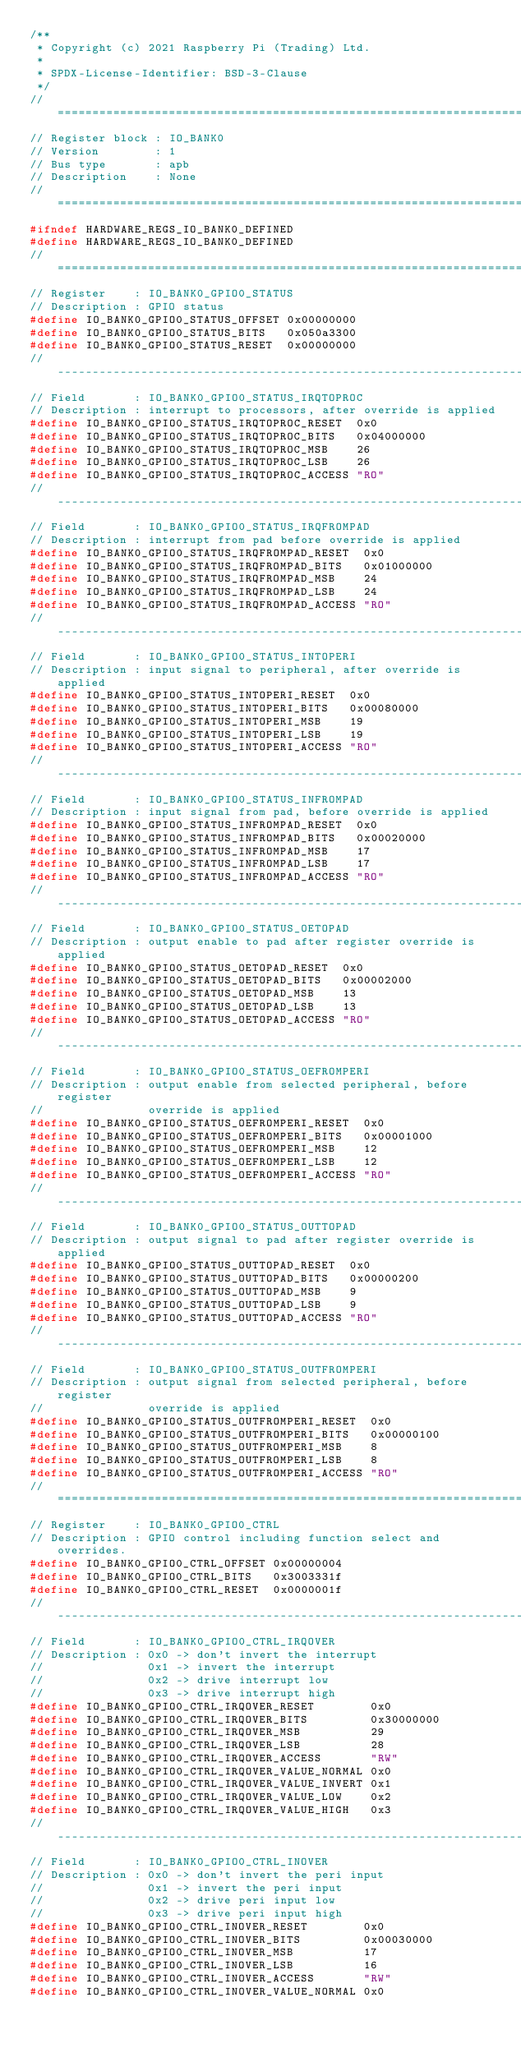<code> <loc_0><loc_0><loc_500><loc_500><_C_>/**
 * Copyright (c) 2021 Raspberry Pi (Trading) Ltd.
 *
 * SPDX-License-Identifier: BSD-3-Clause
 */
// =============================================================================
// Register block : IO_BANK0
// Version        : 1
// Bus type       : apb
// Description    : None
// =============================================================================
#ifndef HARDWARE_REGS_IO_BANK0_DEFINED
#define HARDWARE_REGS_IO_BANK0_DEFINED
// =============================================================================
// Register    : IO_BANK0_GPIO0_STATUS
// Description : GPIO status
#define IO_BANK0_GPIO0_STATUS_OFFSET 0x00000000
#define IO_BANK0_GPIO0_STATUS_BITS   0x050a3300
#define IO_BANK0_GPIO0_STATUS_RESET  0x00000000
// -----------------------------------------------------------------------------
// Field       : IO_BANK0_GPIO0_STATUS_IRQTOPROC
// Description : interrupt to processors, after override is applied
#define IO_BANK0_GPIO0_STATUS_IRQTOPROC_RESET  0x0
#define IO_BANK0_GPIO0_STATUS_IRQTOPROC_BITS   0x04000000
#define IO_BANK0_GPIO0_STATUS_IRQTOPROC_MSB    26
#define IO_BANK0_GPIO0_STATUS_IRQTOPROC_LSB    26
#define IO_BANK0_GPIO0_STATUS_IRQTOPROC_ACCESS "RO"
// -----------------------------------------------------------------------------
// Field       : IO_BANK0_GPIO0_STATUS_IRQFROMPAD
// Description : interrupt from pad before override is applied
#define IO_BANK0_GPIO0_STATUS_IRQFROMPAD_RESET  0x0
#define IO_BANK0_GPIO0_STATUS_IRQFROMPAD_BITS   0x01000000
#define IO_BANK0_GPIO0_STATUS_IRQFROMPAD_MSB    24
#define IO_BANK0_GPIO0_STATUS_IRQFROMPAD_LSB    24
#define IO_BANK0_GPIO0_STATUS_IRQFROMPAD_ACCESS "RO"
// -----------------------------------------------------------------------------
// Field       : IO_BANK0_GPIO0_STATUS_INTOPERI
// Description : input signal to peripheral, after override is applied
#define IO_BANK0_GPIO0_STATUS_INTOPERI_RESET  0x0
#define IO_BANK0_GPIO0_STATUS_INTOPERI_BITS   0x00080000
#define IO_BANK0_GPIO0_STATUS_INTOPERI_MSB    19
#define IO_BANK0_GPIO0_STATUS_INTOPERI_LSB    19
#define IO_BANK0_GPIO0_STATUS_INTOPERI_ACCESS "RO"
// -----------------------------------------------------------------------------
// Field       : IO_BANK0_GPIO0_STATUS_INFROMPAD
// Description : input signal from pad, before override is applied
#define IO_BANK0_GPIO0_STATUS_INFROMPAD_RESET  0x0
#define IO_BANK0_GPIO0_STATUS_INFROMPAD_BITS   0x00020000
#define IO_BANK0_GPIO0_STATUS_INFROMPAD_MSB    17
#define IO_BANK0_GPIO0_STATUS_INFROMPAD_LSB    17
#define IO_BANK0_GPIO0_STATUS_INFROMPAD_ACCESS "RO"
// -----------------------------------------------------------------------------
// Field       : IO_BANK0_GPIO0_STATUS_OETOPAD
// Description : output enable to pad after register override is applied
#define IO_BANK0_GPIO0_STATUS_OETOPAD_RESET  0x0
#define IO_BANK0_GPIO0_STATUS_OETOPAD_BITS   0x00002000
#define IO_BANK0_GPIO0_STATUS_OETOPAD_MSB    13
#define IO_BANK0_GPIO0_STATUS_OETOPAD_LSB    13
#define IO_BANK0_GPIO0_STATUS_OETOPAD_ACCESS "RO"
// -----------------------------------------------------------------------------
// Field       : IO_BANK0_GPIO0_STATUS_OEFROMPERI
// Description : output enable from selected peripheral, before register
//               override is applied
#define IO_BANK0_GPIO0_STATUS_OEFROMPERI_RESET  0x0
#define IO_BANK0_GPIO0_STATUS_OEFROMPERI_BITS   0x00001000
#define IO_BANK0_GPIO0_STATUS_OEFROMPERI_MSB    12
#define IO_BANK0_GPIO0_STATUS_OEFROMPERI_LSB    12
#define IO_BANK0_GPIO0_STATUS_OEFROMPERI_ACCESS "RO"
// -----------------------------------------------------------------------------
// Field       : IO_BANK0_GPIO0_STATUS_OUTTOPAD
// Description : output signal to pad after register override is applied
#define IO_BANK0_GPIO0_STATUS_OUTTOPAD_RESET  0x0
#define IO_BANK0_GPIO0_STATUS_OUTTOPAD_BITS   0x00000200
#define IO_BANK0_GPIO0_STATUS_OUTTOPAD_MSB    9
#define IO_BANK0_GPIO0_STATUS_OUTTOPAD_LSB    9
#define IO_BANK0_GPIO0_STATUS_OUTTOPAD_ACCESS "RO"
// -----------------------------------------------------------------------------
// Field       : IO_BANK0_GPIO0_STATUS_OUTFROMPERI
// Description : output signal from selected peripheral, before register
//               override is applied
#define IO_BANK0_GPIO0_STATUS_OUTFROMPERI_RESET  0x0
#define IO_BANK0_GPIO0_STATUS_OUTFROMPERI_BITS   0x00000100
#define IO_BANK0_GPIO0_STATUS_OUTFROMPERI_MSB    8
#define IO_BANK0_GPIO0_STATUS_OUTFROMPERI_LSB    8
#define IO_BANK0_GPIO0_STATUS_OUTFROMPERI_ACCESS "RO"
// =============================================================================
// Register    : IO_BANK0_GPIO0_CTRL
// Description : GPIO control including function select and overrides.
#define IO_BANK0_GPIO0_CTRL_OFFSET 0x00000004
#define IO_BANK0_GPIO0_CTRL_BITS   0x3003331f
#define IO_BANK0_GPIO0_CTRL_RESET  0x0000001f
// -----------------------------------------------------------------------------
// Field       : IO_BANK0_GPIO0_CTRL_IRQOVER
// Description : 0x0 -> don't invert the interrupt
//               0x1 -> invert the interrupt
//               0x2 -> drive interrupt low
//               0x3 -> drive interrupt high
#define IO_BANK0_GPIO0_CTRL_IRQOVER_RESET        0x0
#define IO_BANK0_GPIO0_CTRL_IRQOVER_BITS         0x30000000
#define IO_BANK0_GPIO0_CTRL_IRQOVER_MSB          29
#define IO_BANK0_GPIO0_CTRL_IRQOVER_LSB          28
#define IO_BANK0_GPIO0_CTRL_IRQOVER_ACCESS       "RW"
#define IO_BANK0_GPIO0_CTRL_IRQOVER_VALUE_NORMAL 0x0
#define IO_BANK0_GPIO0_CTRL_IRQOVER_VALUE_INVERT 0x1
#define IO_BANK0_GPIO0_CTRL_IRQOVER_VALUE_LOW    0x2
#define IO_BANK0_GPIO0_CTRL_IRQOVER_VALUE_HIGH   0x3
// -----------------------------------------------------------------------------
// Field       : IO_BANK0_GPIO0_CTRL_INOVER
// Description : 0x0 -> don't invert the peri input
//               0x1 -> invert the peri input
//               0x2 -> drive peri input low
//               0x3 -> drive peri input high
#define IO_BANK0_GPIO0_CTRL_INOVER_RESET        0x0
#define IO_BANK0_GPIO0_CTRL_INOVER_BITS         0x00030000
#define IO_BANK0_GPIO0_CTRL_INOVER_MSB          17
#define IO_BANK0_GPIO0_CTRL_INOVER_LSB          16
#define IO_BANK0_GPIO0_CTRL_INOVER_ACCESS       "RW"
#define IO_BANK0_GPIO0_CTRL_INOVER_VALUE_NORMAL 0x0</code> 